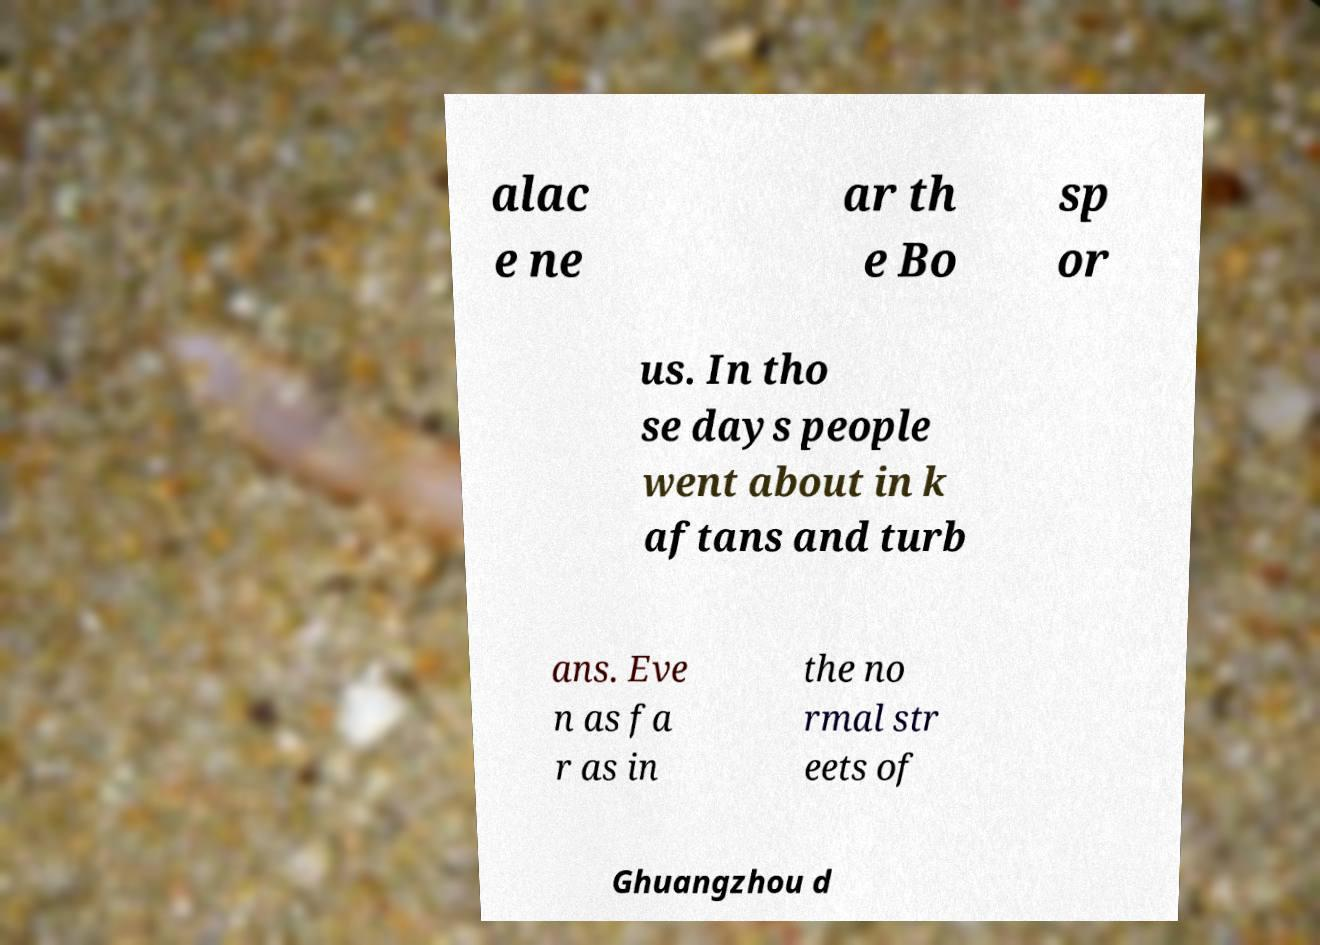What messages or text are displayed in this image? I need them in a readable, typed format. alac e ne ar th e Bo sp or us. In tho se days people went about in k aftans and turb ans. Eve n as fa r as in the no rmal str eets of Ghuangzhou d 